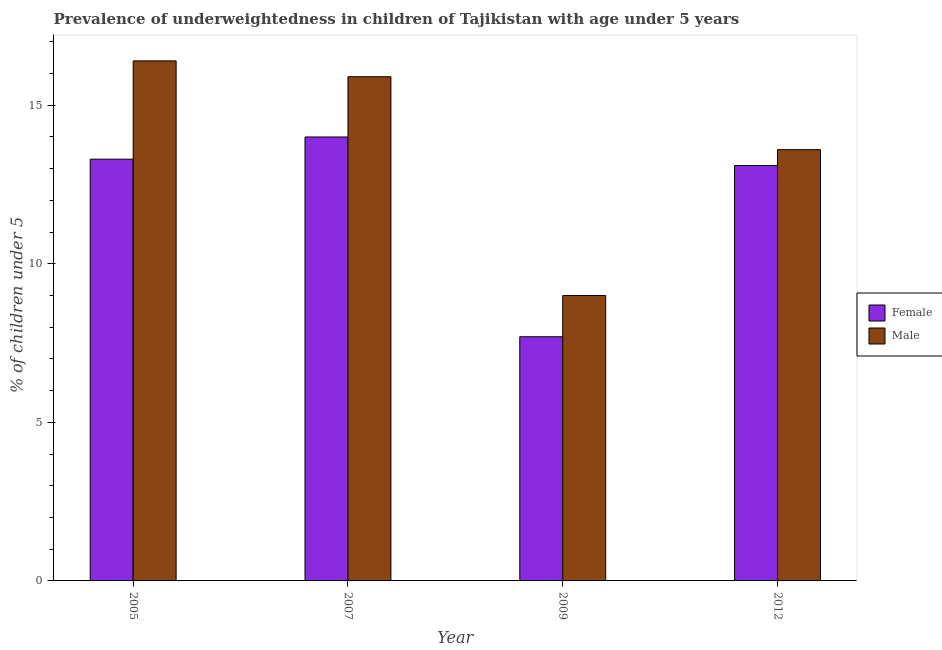How many different coloured bars are there?
Your answer should be compact. 2. How many groups of bars are there?
Your answer should be very brief. 4. What is the label of the 1st group of bars from the left?
Give a very brief answer. 2005. What is the percentage of underweighted female children in 2007?
Your answer should be compact. 14. Across all years, what is the maximum percentage of underweighted male children?
Your answer should be compact. 16.4. Across all years, what is the minimum percentage of underweighted male children?
Your answer should be compact. 9. In which year was the percentage of underweighted male children maximum?
Your answer should be compact. 2005. In which year was the percentage of underweighted male children minimum?
Keep it short and to the point. 2009. What is the total percentage of underweighted female children in the graph?
Provide a succinct answer. 48.1. What is the difference between the percentage of underweighted male children in 2005 and that in 2007?
Your answer should be very brief. 0.5. What is the difference between the percentage of underweighted male children in 2005 and the percentage of underweighted female children in 2007?
Provide a succinct answer. 0.5. What is the average percentage of underweighted female children per year?
Provide a short and direct response. 12.03. In how many years, is the percentage of underweighted female children greater than 15 %?
Provide a short and direct response. 0. What is the ratio of the percentage of underweighted male children in 2007 to that in 2012?
Keep it short and to the point. 1.17. Is the percentage of underweighted female children in 2007 less than that in 2012?
Make the answer very short. No. What is the difference between the highest and the second highest percentage of underweighted female children?
Give a very brief answer. 0.7. What is the difference between the highest and the lowest percentage of underweighted male children?
Give a very brief answer. 7.4. In how many years, is the percentage of underweighted male children greater than the average percentage of underweighted male children taken over all years?
Your response must be concise. 2. Is the sum of the percentage of underweighted female children in 2005 and 2009 greater than the maximum percentage of underweighted male children across all years?
Provide a short and direct response. Yes. What does the 2nd bar from the left in 2005 represents?
Keep it short and to the point. Male. How many bars are there?
Offer a very short reply. 8. How many years are there in the graph?
Keep it short and to the point. 4. Are the values on the major ticks of Y-axis written in scientific E-notation?
Offer a terse response. No. Does the graph contain any zero values?
Make the answer very short. No. Does the graph contain grids?
Give a very brief answer. No. How many legend labels are there?
Offer a terse response. 2. What is the title of the graph?
Give a very brief answer. Prevalence of underweightedness in children of Tajikistan with age under 5 years. Does "Education" appear as one of the legend labels in the graph?
Offer a very short reply. No. What is the label or title of the X-axis?
Your response must be concise. Year. What is the label or title of the Y-axis?
Give a very brief answer.  % of children under 5. What is the  % of children under 5 in Female in 2005?
Your answer should be very brief. 13.3. What is the  % of children under 5 of Male in 2005?
Your response must be concise. 16.4. What is the  % of children under 5 in Female in 2007?
Offer a terse response. 14. What is the  % of children under 5 of Male in 2007?
Give a very brief answer. 15.9. What is the  % of children under 5 in Female in 2009?
Make the answer very short. 7.7. What is the  % of children under 5 of Female in 2012?
Offer a terse response. 13.1. What is the  % of children under 5 of Male in 2012?
Provide a succinct answer. 13.6. Across all years, what is the maximum  % of children under 5 of Male?
Offer a very short reply. 16.4. Across all years, what is the minimum  % of children under 5 of Female?
Keep it short and to the point. 7.7. What is the total  % of children under 5 in Female in the graph?
Keep it short and to the point. 48.1. What is the total  % of children under 5 of Male in the graph?
Provide a succinct answer. 54.9. What is the difference between the  % of children under 5 of Female in 2005 and that in 2007?
Offer a terse response. -0.7. What is the difference between the  % of children under 5 in Male in 2005 and that in 2012?
Your answer should be very brief. 2.8. What is the difference between the  % of children under 5 of Female in 2007 and that in 2009?
Ensure brevity in your answer.  6.3. What is the difference between the  % of children under 5 in Female in 2007 and that in 2012?
Make the answer very short. 0.9. What is the difference between the  % of children under 5 in Male in 2007 and that in 2012?
Provide a short and direct response. 2.3. What is the difference between the  % of children under 5 in Female in 2009 and that in 2012?
Ensure brevity in your answer.  -5.4. What is the difference between the  % of children under 5 in Female in 2005 and the  % of children under 5 in Male in 2009?
Offer a terse response. 4.3. What is the difference between the  % of children under 5 in Female in 2007 and the  % of children under 5 in Male in 2009?
Provide a succinct answer. 5. What is the difference between the  % of children under 5 in Female in 2007 and the  % of children under 5 in Male in 2012?
Offer a terse response. 0.4. What is the difference between the  % of children under 5 in Female in 2009 and the  % of children under 5 in Male in 2012?
Make the answer very short. -5.9. What is the average  % of children under 5 in Female per year?
Give a very brief answer. 12.03. What is the average  % of children under 5 of Male per year?
Your response must be concise. 13.72. In the year 2005, what is the difference between the  % of children under 5 of Female and  % of children under 5 of Male?
Keep it short and to the point. -3.1. In the year 2007, what is the difference between the  % of children under 5 in Female and  % of children under 5 in Male?
Provide a short and direct response. -1.9. What is the ratio of the  % of children under 5 in Female in 2005 to that in 2007?
Your answer should be very brief. 0.95. What is the ratio of the  % of children under 5 in Male in 2005 to that in 2007?
Your answer should be compact. 1.03. What is the ratio of the  % of children under 5 in Female in 2005 to that in 2009?
Provide a short and direct response. 1.73. What is the ratio of the  % of children under 5 of Male in 2005 to that in 2009?
Give a very brief answer. 1.82. What is the ratio of the  % of children under 5 of Female in 2005 to that in 2012?
Offer a terse response. 1.02. What is the ratio of the  % of children under 5 of Male in 2005 to that in 2012?
Your response must be concise. 1.21. What is the ratio of the  % of children under 5 in Female in 2007 to that in 2009?
Offer a very short reply. 1.82. What is the ratio of the  % of children under 5 in Male in 2007 to that in 2009?
Provide a succinct answer. 1.77. What is the ratio of the  % of children under 5 of Female in 2007 to that in 2012?
Your answer should be compact. 1.07. What is the ratio of the  % of children under 5 in Male in 2007 to that in 2012?
Your response must be concise. 1.17. What is the ratio of the  % of children under 5 of Female in 2009 to that in 2012?
Give a very brief answer. 0.59. What is the ratio of the  % of children under 5 in Male in 2009 to that in 2012?
Make the answer very short. 0.66. What is the difference between the highest and the second highest  % of children under 5 of Female?
Provide a short and direct response. 0.7. What is the difference between the highest and the second highest  % of children under 5 of Male?
Ensure brevity in your answer.  0.5. What is the difference between the highest and the lowest  % of children under 5 of Female?
Provide a short and direct response. 6.3. 